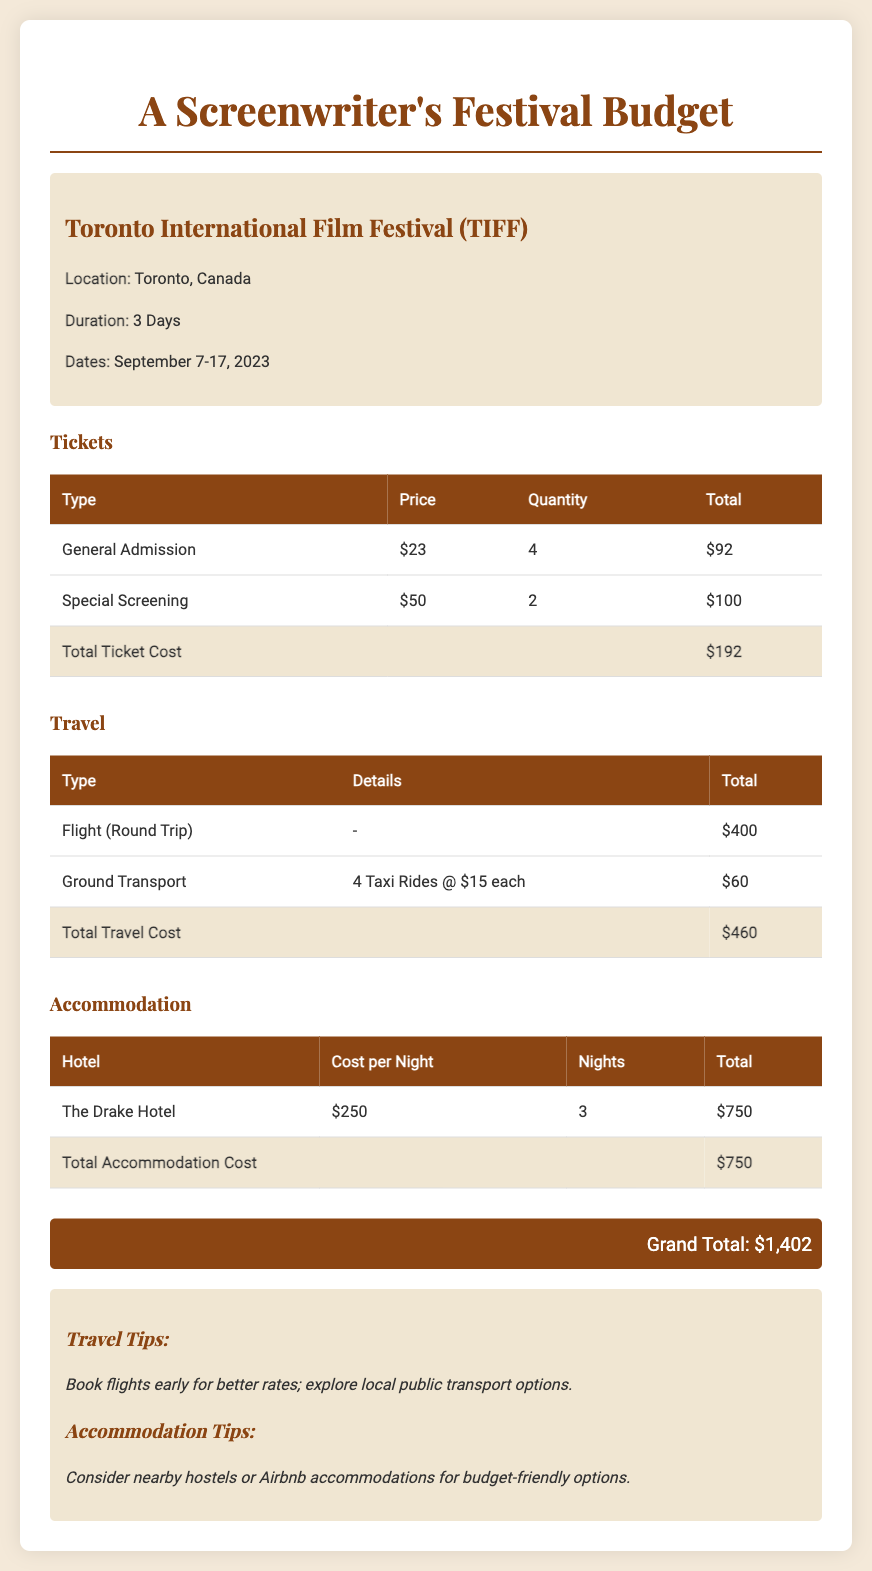what is the location of the film festival? The location of the film festival is specified as Toronto, Canada in the event details.
Answer: Toronto, Canada how many days does the festival last? The duration of the festival is stated as 3 Days in the event details.
Answer: 3 Days what is the total ticket cost? The total ticket cost is calculated in the tickets section, summed from different types of ticket purchases.
Answer: $192 how much does a round trip flight cost? The cost of the round trip flight is detailed in the travel section, showing a specific total for this item.
Answer: $400 how many taxi rides are included in the ground transport cost? The document states that there are 4 taxi rides included in the ground transport cost breakdown.
Answer: 4 what is the cost per night at The Drake Hotel? The cost per night for accommodation at The Drake Hotel is specifically listed in the accommodation section.
Answer: $250 what is the grand total of the budget? The grand total is the overall sum of tickets, travel, and accommodation costs as presented at the end of the document.
Answer: $1,402 what type of event is the budget for? The budget is specifically for a film festival, mentioned in the title and event details.
Answer: Film Festival what is a travel tip mentioned in the document? The document includes a travel tip related to booking flights early for better rates, mentioned in the notes section.
Answer: Book flights early what is a recommended accommodation option for budget-friendly options? The notes suggest considering nearby hostels or Airbnb accommodations for budget-friendly options.
Answer: Hostels or Airbnb 